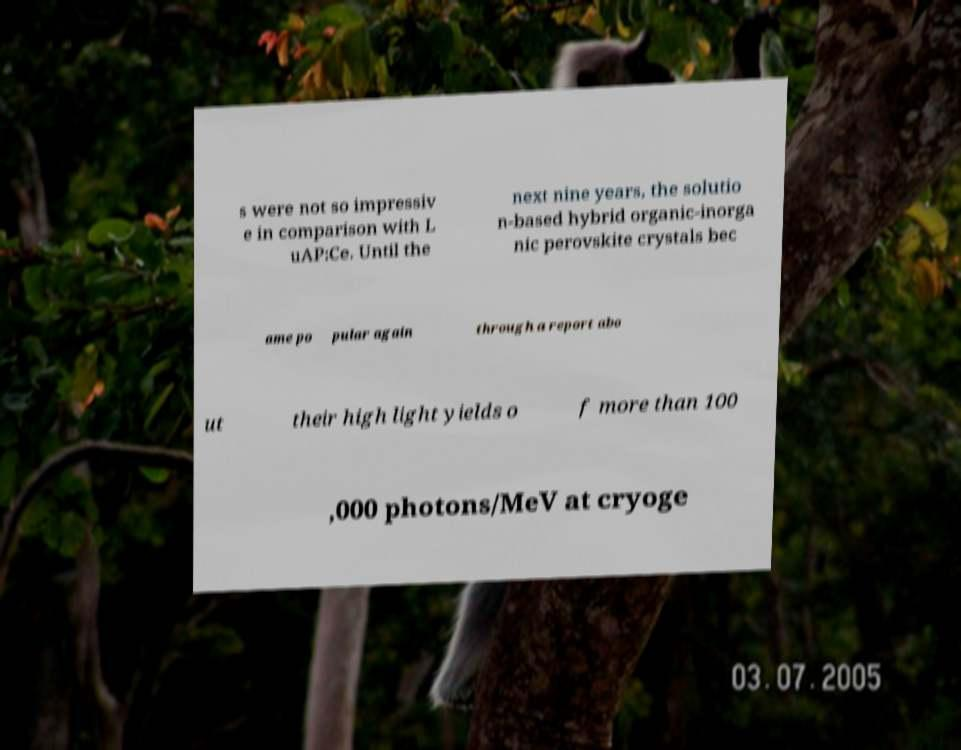I need the written content from this picture converted into text. Can you do that? s were not so impressiv e in comparison with L uAP:Ce. Until the next nine years, the solutio n-based hybrid organic-inorga nic perovskite crystals bec ame po pular again through a report abo ut their high light yields o f more than 100 ,000 photons/MeV at cryoge 